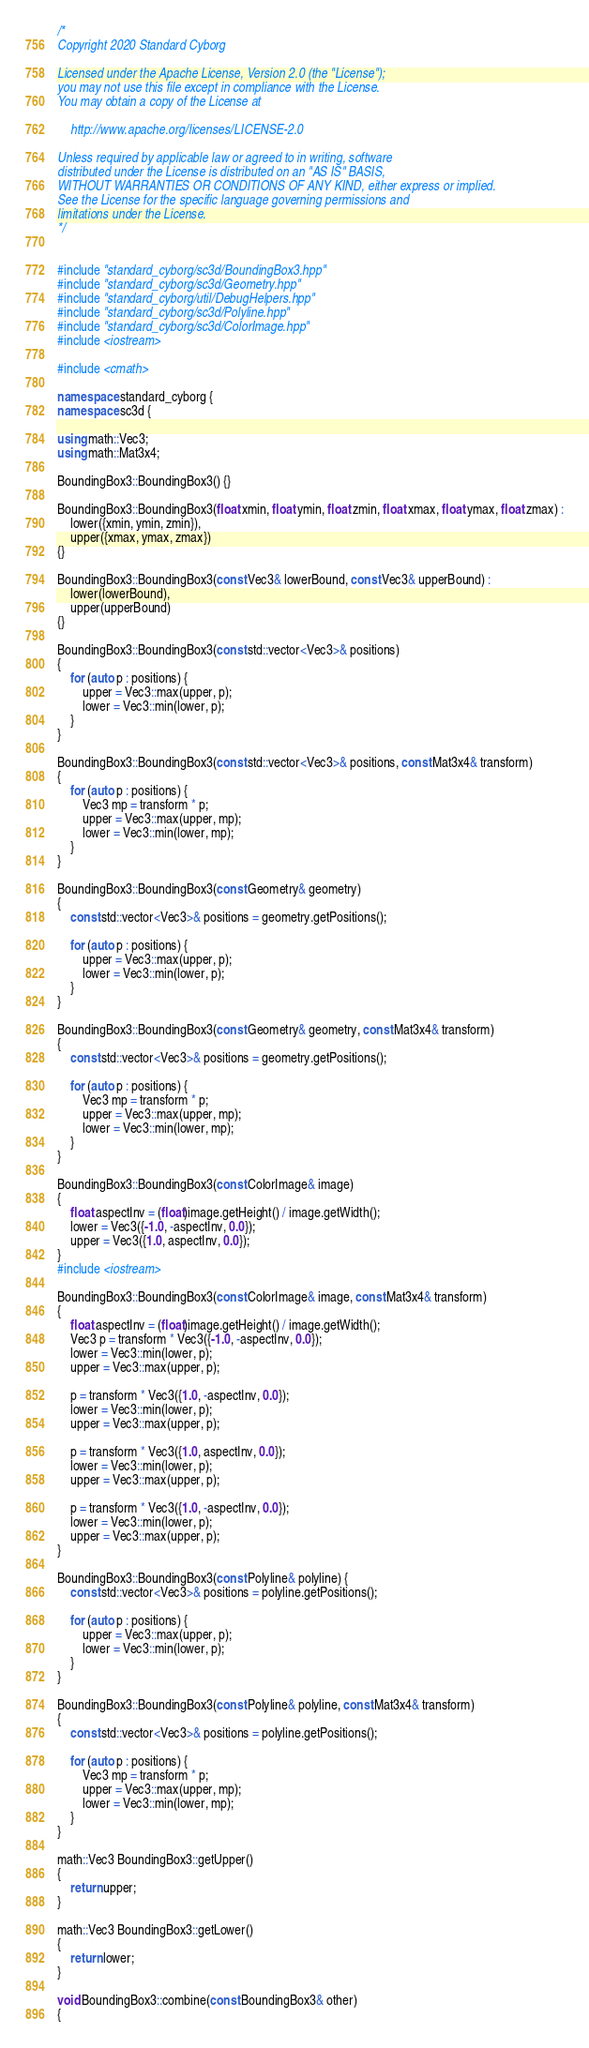Convert code to text. <code><loc_0><loc_0><loc_500><loc_500><_C++_>/*
Copyright 2020 Standard Cyborg

Licensed under the Apache License, Version 2.0 (the "License");
you may not use this file except in compliance with the License.
You may obtain a copy of the License at

    http://www.apache.org/licenses/LICENSE-2.0

Unless required by applicable law or agreed to in writing, software
distributed under the License is distributed on an "AS IS" BASIS,
WITHOUT WARRANTIES OR CONDITIONS OF ANY KIND, either express or implied.
See the License for the specific language governing permissions and
limitations under the License.
*/


#include "standard_cyborg/sc3d/BoundingBox3.hpp"
#include "standard_cyborg/sc3d/Geometry.hpp"
#include "standard_cyborg/util/DebugHelpers.hpp"
#include "standard_cyborg/sc3d/Polyline.hpp"
#include "standard_cyborg/sc3d/ColorImage.hpp"
#include <iostream>

#include <cmath>

namespace standard_cyborg {
namespace sc3d {

using math::Vec3;
using math::Mat3x4;

BoundingBox3::BoundingBox3() {}

BoundingBox3::BoundingBox3(float xmin, float ymin, float zmin, float xmax, float ymax, float zmax) :
    lower({xmin, ymin, zmin}),
    upper({xmax, ymax, zmax})
{}

BoundingBox3::BoundingBox3(const Vec3& lowerBound, const Vec3& upperBound) :
    lower(lowerBound),
    upper(upperBound)
{}

BoundingBox3::BoundingBox3(const std::vector<Vec3>& positions)
{
    for (auto p : positions) {
        upper = Vec3::max(upper, p);
        lower = Vec3::min(lower, p);
    }
}

BoundingBox3::BoundingBox3(const std::vector<Vec3>& positions, const Mat3x4& transform)
{
    for (auto p : positions) {
        Vec3 mp = transform * p;
        upper = Vec3::max(upper, mp);
        lower = Vec3::min(lower, mp);
    }
}

BoundingBox3::BoundingBox3(const Geometry& geometry)
{
    const std::vector<Vec3>& positions = geometry.getPositions();
    
    for (auto p : positions) {
        upper = Vec3::max(upper, p);
        lower = Vec3::min(lower, p);
    }
}

BoundingBox3::BoundingBox3(const Geometry& geometry, const Mat3x4& transform)
{
    const std::vector<Vec3>& positions = geometry.getPositions();
    
    for (auto p : positions) {
        Vec3 mp = transform * p;
        upper = Vec3::max(upper, mp);
        lower = Vec3::min(lower, mp);
    }
}

BoundingBox3::BoundingBox3(const ColorImage& image)
{
    float aspectInv = (float)image.getHeight() / image.getWidth();
    lower = Vec3({-1.0, -aspectInv, 0.0});
    upper = Vec3({1.0, aspectInv, 0.0});
}
#include <iostream>

BoundingBox3::BoundingBox3(const ColorImage& image, const Mat3x4& transform)
{
    float aspectInv = (float)image.getHeight() / image.getWidth();
    Vec3 p = transform * Vec3({-1.0, -aspectInv, 0.0});
    lower = Vec3::min(lower, p);
    upper = Vec3::max(upper, p);
    
    p = transform * Vec3({1.0, -aspectInv, 0.0});
    lower = Vec3::min(lower, p);
    upper = Vec3::max(upper, p);
    
    p = transform * Vec3({1.0, aspectInv, 0.0});
    lower = Vec3::min(lower, p);
    upper = Vec3::max(upper, p);
    
    p = transform * Vec3({1.0, -aspectInv, 0.0});
    lower = Vec3::min(lower, p);
    upper = Vec3::max(upper, p);
}

BoundingBox3::BoundingBox3(const Polyline& polyline) {
    const std::vector<Vec3>& positions = polyline.getPositions();
    
    for (auto p : positions) {
        upper = Vec3::max(upper, p);
        lower = Vec3::min(lower, p);
    }
}

BoundingBox3::BoundingBox3(const Polyline& polyline, const Mat3x4& transform)
{
    const std::vector<Vec3>& positions = polyline.getPositions();
    
    for (auto p : positions) {
        Vec3 mp = transform * p;
        upper = Vec3::max(upper, mp);
        lower = Vec3::min(lower, mp);
    }
}

math::Vec3 BoundingBox3::getUpper()
{
    return upper;
}

math::Vec3 BoundingBox3::getLower()
{
    return lower;
}

void BoundingBox3::combine(const BoundingBox3& other)
{</code> 